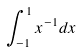Convert formula to latex. <formula><loc_0><loc_0><loc_500><loc_500>\int _ { - 1 } ^ { 1 } x ^ { - 1 } d x</formula> 